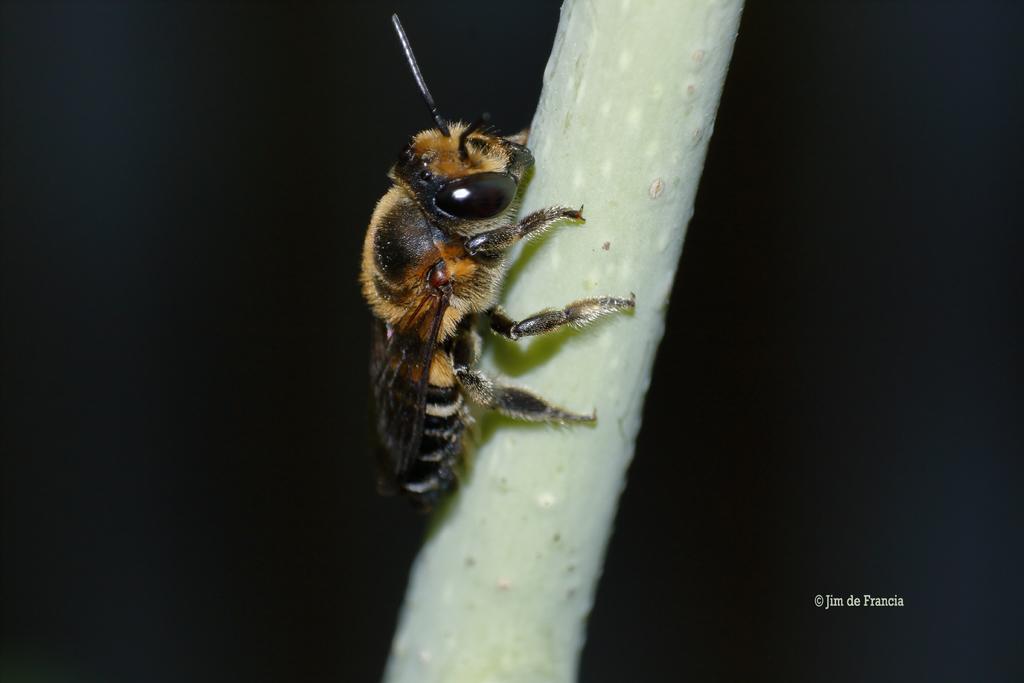How would you summarize this image in a sentence or two? In this image in the center there is an insect. 